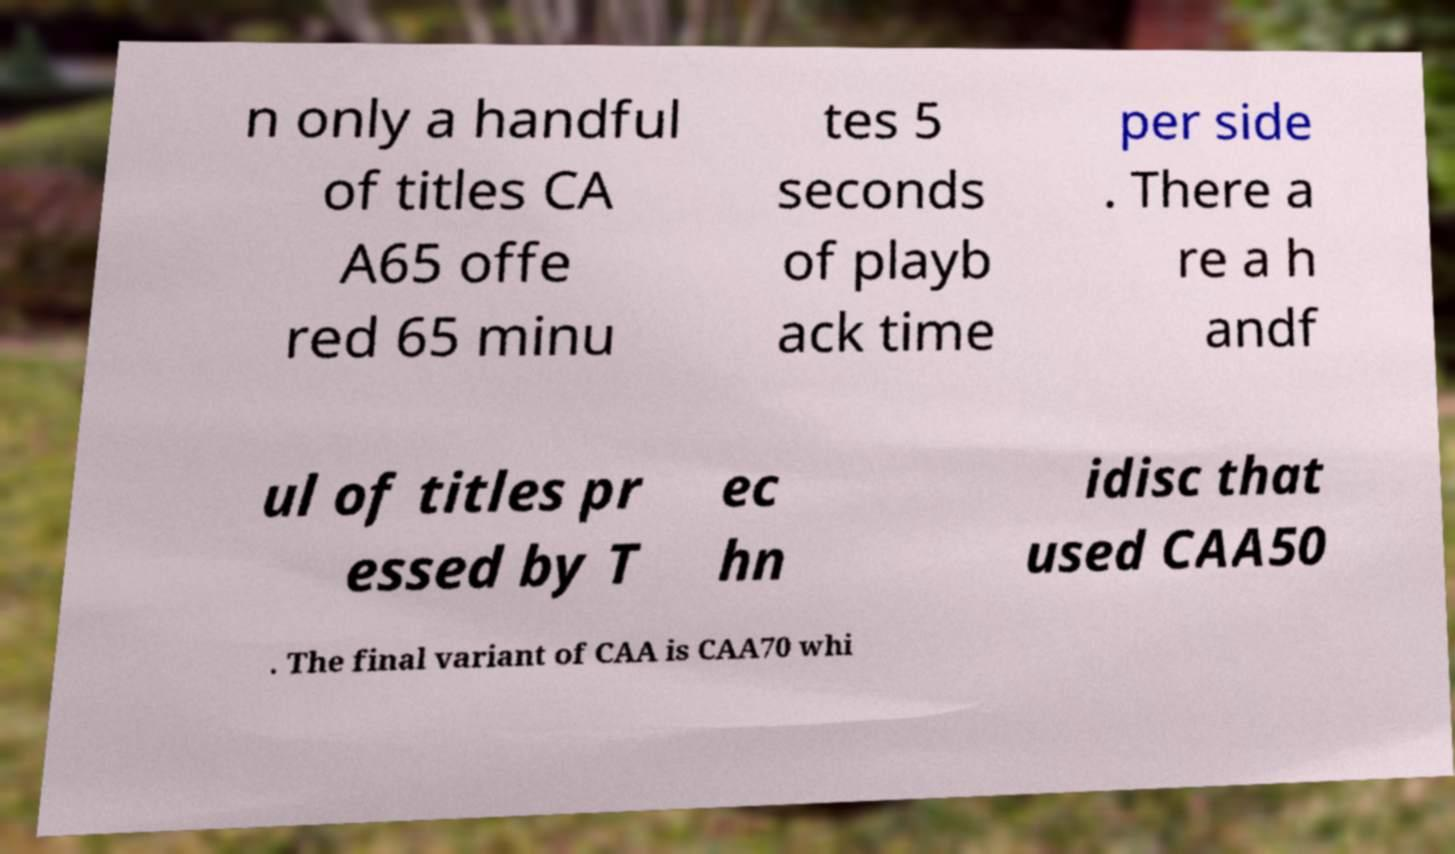Please identify and transcribe the text found in this image. n only a handful of titles CA A65 offe red 65 minu tes 5 seconds of playb ack time per side . There a re a h andf ul of titles pr essed by T ec hn idisc that used CAA50 . The final variant of CAA is CAA70 whi 